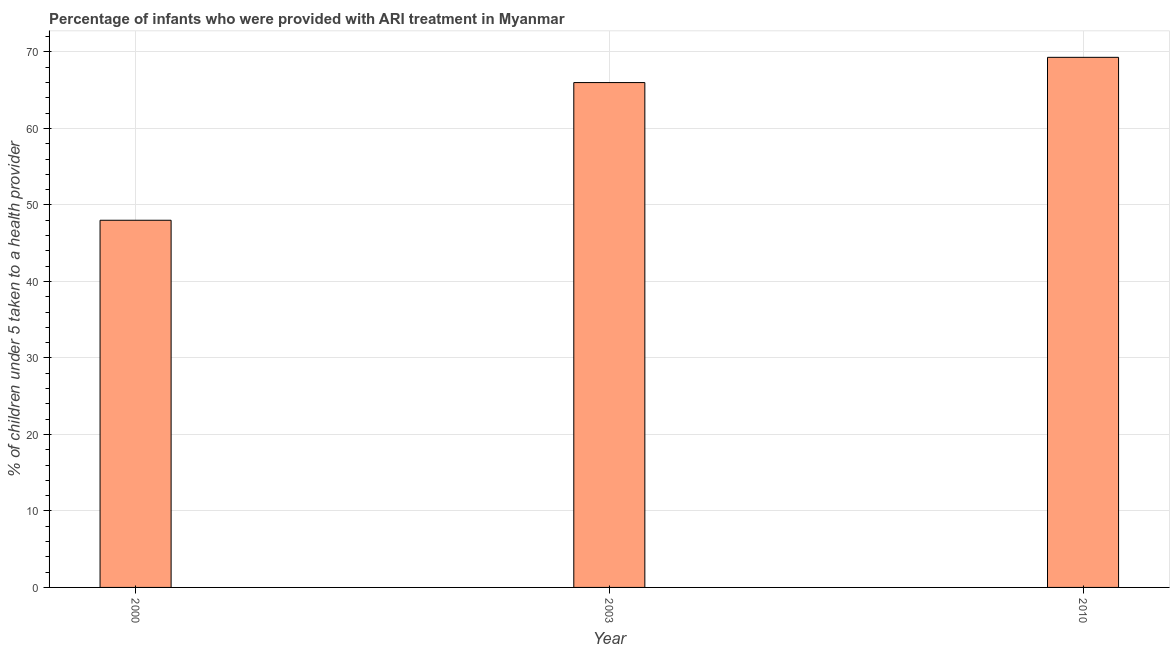Does the graph contain any zero values?
Make the answer very short. No. Does the graph contain grids?
Provide a short and direct response. Yes. What is the title of the graph?
Your answer should be very brief. Percentage of infants who were provided with ARI treatment in Myanmar. What is the label or title of the Y-axis?
Your response must be concise. % of children under 5 taken to a health provider. Across all years, what is the maximum percentage of children who were provided with ari treatment?
Your answer should be compact. 69.3. Across all years, what is the minimum percentage of children who were provided with ari treatment?
Your answer should be compact. 48. In which year was the percentage of children who were provided with ari treatment maximum?
Offer a terse response. 2010. What is the sum of the percentage of children who were provided with ari treatment?
Offer a terse response. 183.3. What is the average percentage of children who were provided with ari treatment per year?
Your answer should be compact. 61.1. What is the median percentage of children who were provided with ari treatment?
Make the answer very short. 66. Do a majority of the years between 2003 and 2010 (inclusive) have percentage of children who were provided with ari treatment greater than 66 %?
Keep it short and to the point. No. What is the ratio of the percentage of children who were provided with ari treatment in 2000 to that in 2010?
Offer a very short reply. 0.69. What is the difference between the highest and the lowest percentage of children who were provided with ari treatment?
Provide a short and direct response. 21.3. How many years are there in the graph?
Provide a short and direct response. 3. Are the values on the major ticks of Y-axis written in scientific E-notation?
Keep it short and to the point. No. What is the % of children under 5 taken to a health provider in 2010?
Your answer should be very brief. 69.3. What is the difference between the % of children under 5 taken to a health provider in 2000 and 2003?
Ensure brevity in your answer.  -18. What is the difference between the % of children under 5 taken to a health provider in 2000 and 2010?
Offer a very short reply. -21.3. What is the ratio of the % of children under 5 taken to a health provider in 2000 to that in 2003?
Your response must be concise. 0.73. What is the ratio of the % of children under 5 taken to a health provider in 2000 to that in 2010?
Provide a short and direct response. 0.69. What is the ratio of the % of children under 5 taken to a health provider in 2003 to that in 2010?
Offer a very short reply. 0.95. 